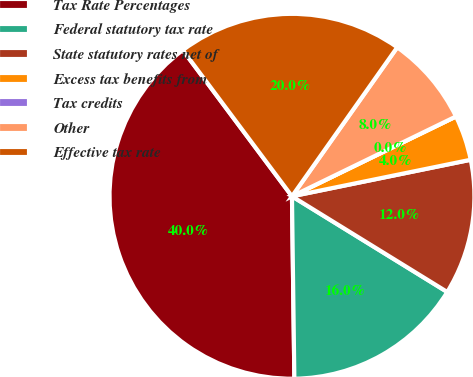Convert chart to OTSL. <chart><loc_0><loc_0><loc_500><loc_500><pie_chart><fcel>Tax Rate Percentages<fcel>Federal statutory tax rate<fcel>State statutory rates net of<fcel>Excess tax benefits from<fcel>Tax credits<fcel>Other<fcel>Effective tax rate<nl><fcel>40.0%<fcel>16.0%<fcel>12.0%<fcel>4.0%<fcel>0.0%<fcel>8.0%<fcel>20.0%<nl></chart> 